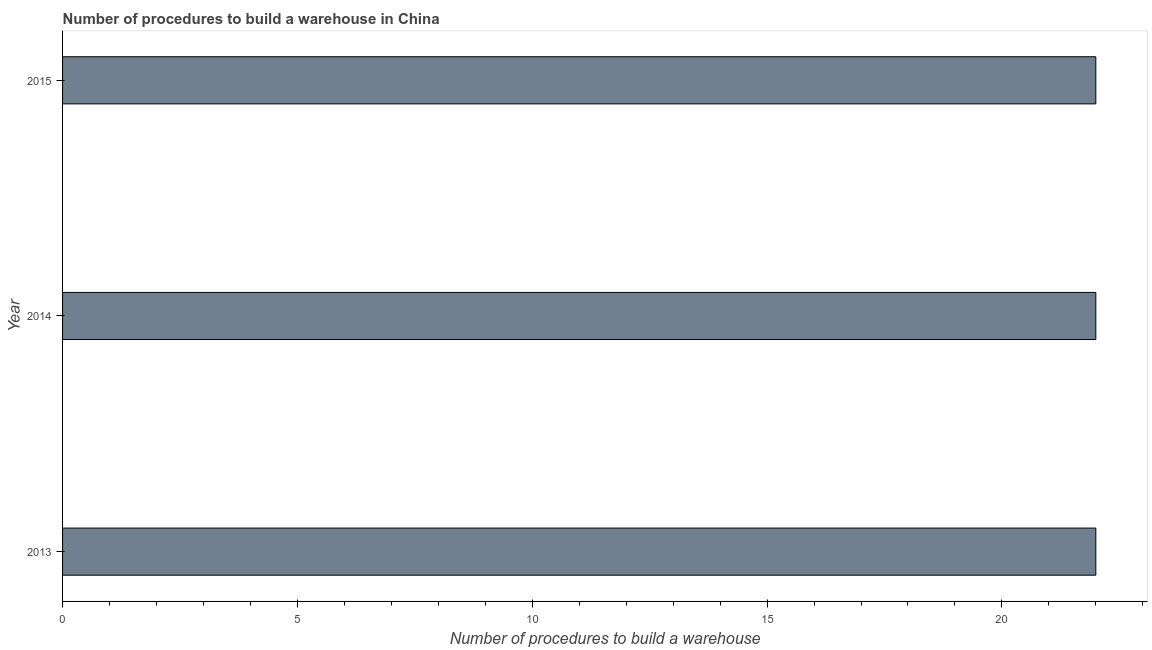Does the graph contain any zero values?
Offer a very short reply. No. What is the title of the graph?
Your response must be concise. Number of procedures to build a warehouse in China. What is the label or title of the X-axis?
Offer a terse response. Number of procedures to build a warehouse. What is the label or title of the Y-axis?
Offer a very short reply. Year. Across all years, what is the maximum number of procedures to build a warehouse?
Your answer should be compact. 22. What is the sum of the number of procedures to build a warehouse?
Offer a very short reply. 66. What is the difference between the number of procedures to build a warehouse in 2014 and 2015?
Your answer should be compact. 0. What is the median number of procedures to build a warehouse?
Ensure brevity in your answer.  22. In how many years, is the number of procedures to build a warehouse greater than 11 ?
Ensure brevity in your answer.  3. Do a majority of the years between 2014 and 2013 (inclusive) have number of procedures to build a warehouse greater than 14 ?
Your answer should be compact. No. What is the ratio of the number of procedures to build a warehouse in 2014 to that in 2015?
Offer a terse response. 1. Is the difference between the number of procedures to build a warehouse in 2013 and 2015 greater than the difference between any two years?
Your answer should be very brief. Yes. Is the sum of the number of procedures to build a warehouse in 2014 and 2015 greater than the maximum number of procedures to build a warehouse across all years?
Your answer should be compact. Yes. What is the difference between the highest and the lowest number of procedures to build a warehouse?
Your response must be concise. 0. How many bars are there?
Your answer should be very brief. 3. Are the values on the major ticks of X-axis written in scientific E-notation?
Your answer should be very brief. No. What is the Number of procedures to build a warehouse in 2013?
Your response must be concise. 22. What is the Number of procedures to build a warehouse in 2015?
Give a very brief answer. 22. What is the difference between the Number of procedures to build a warehouse in 2013 and 2015?
Offer a very short reply. 0. What is the ratio of the Number of procedures to build a warehouse in 2013 to that in 2014?
Keep it short and to the point. 1. What is the ratio of the Number of procedures to build a warehouse in 2014 to that in 2015?
Keep it short and to the point. 1. 